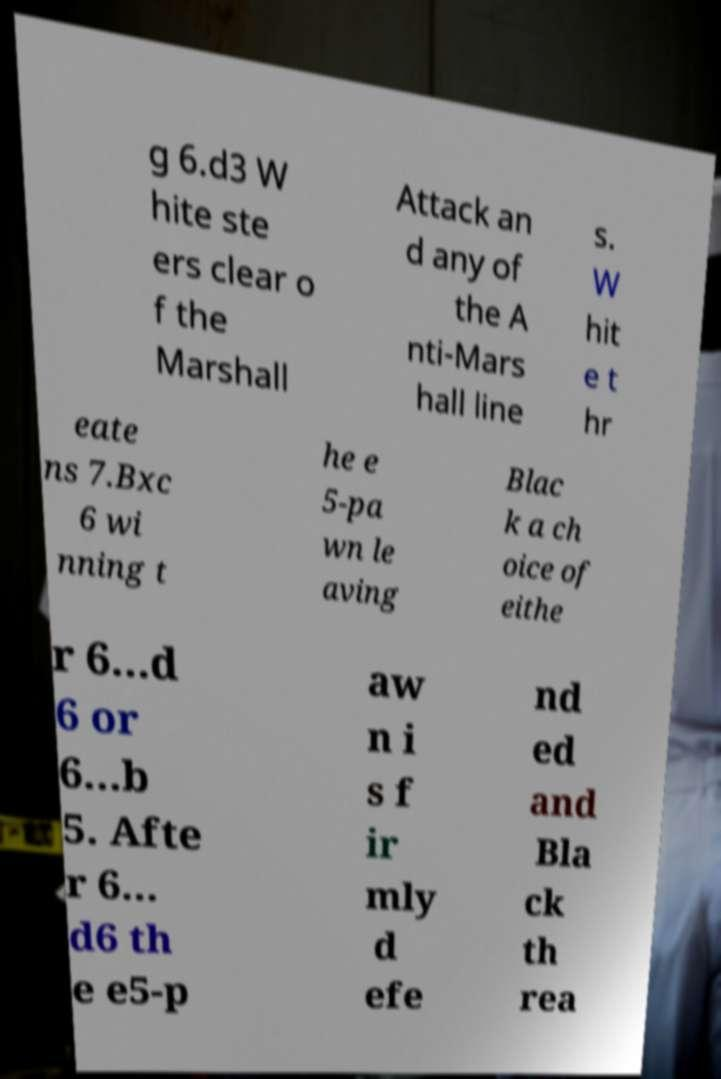Could you assist in decoding the text presented in this image and type it out clearly? g 6.d3 W hite ste ers clear o f the Marshall Attack an d any of the A nti-Mars hall line s. W hit e t hr eate ns 7.Bxc 6 wi nning t he e 5-pa wn le aving Blac k a ch oice of eithe r 6...d 6 or 6...b 5. Afte r 6... d6 th e e5-p aw n i s f ir mly d efe nd ed and Bla ck th rea 